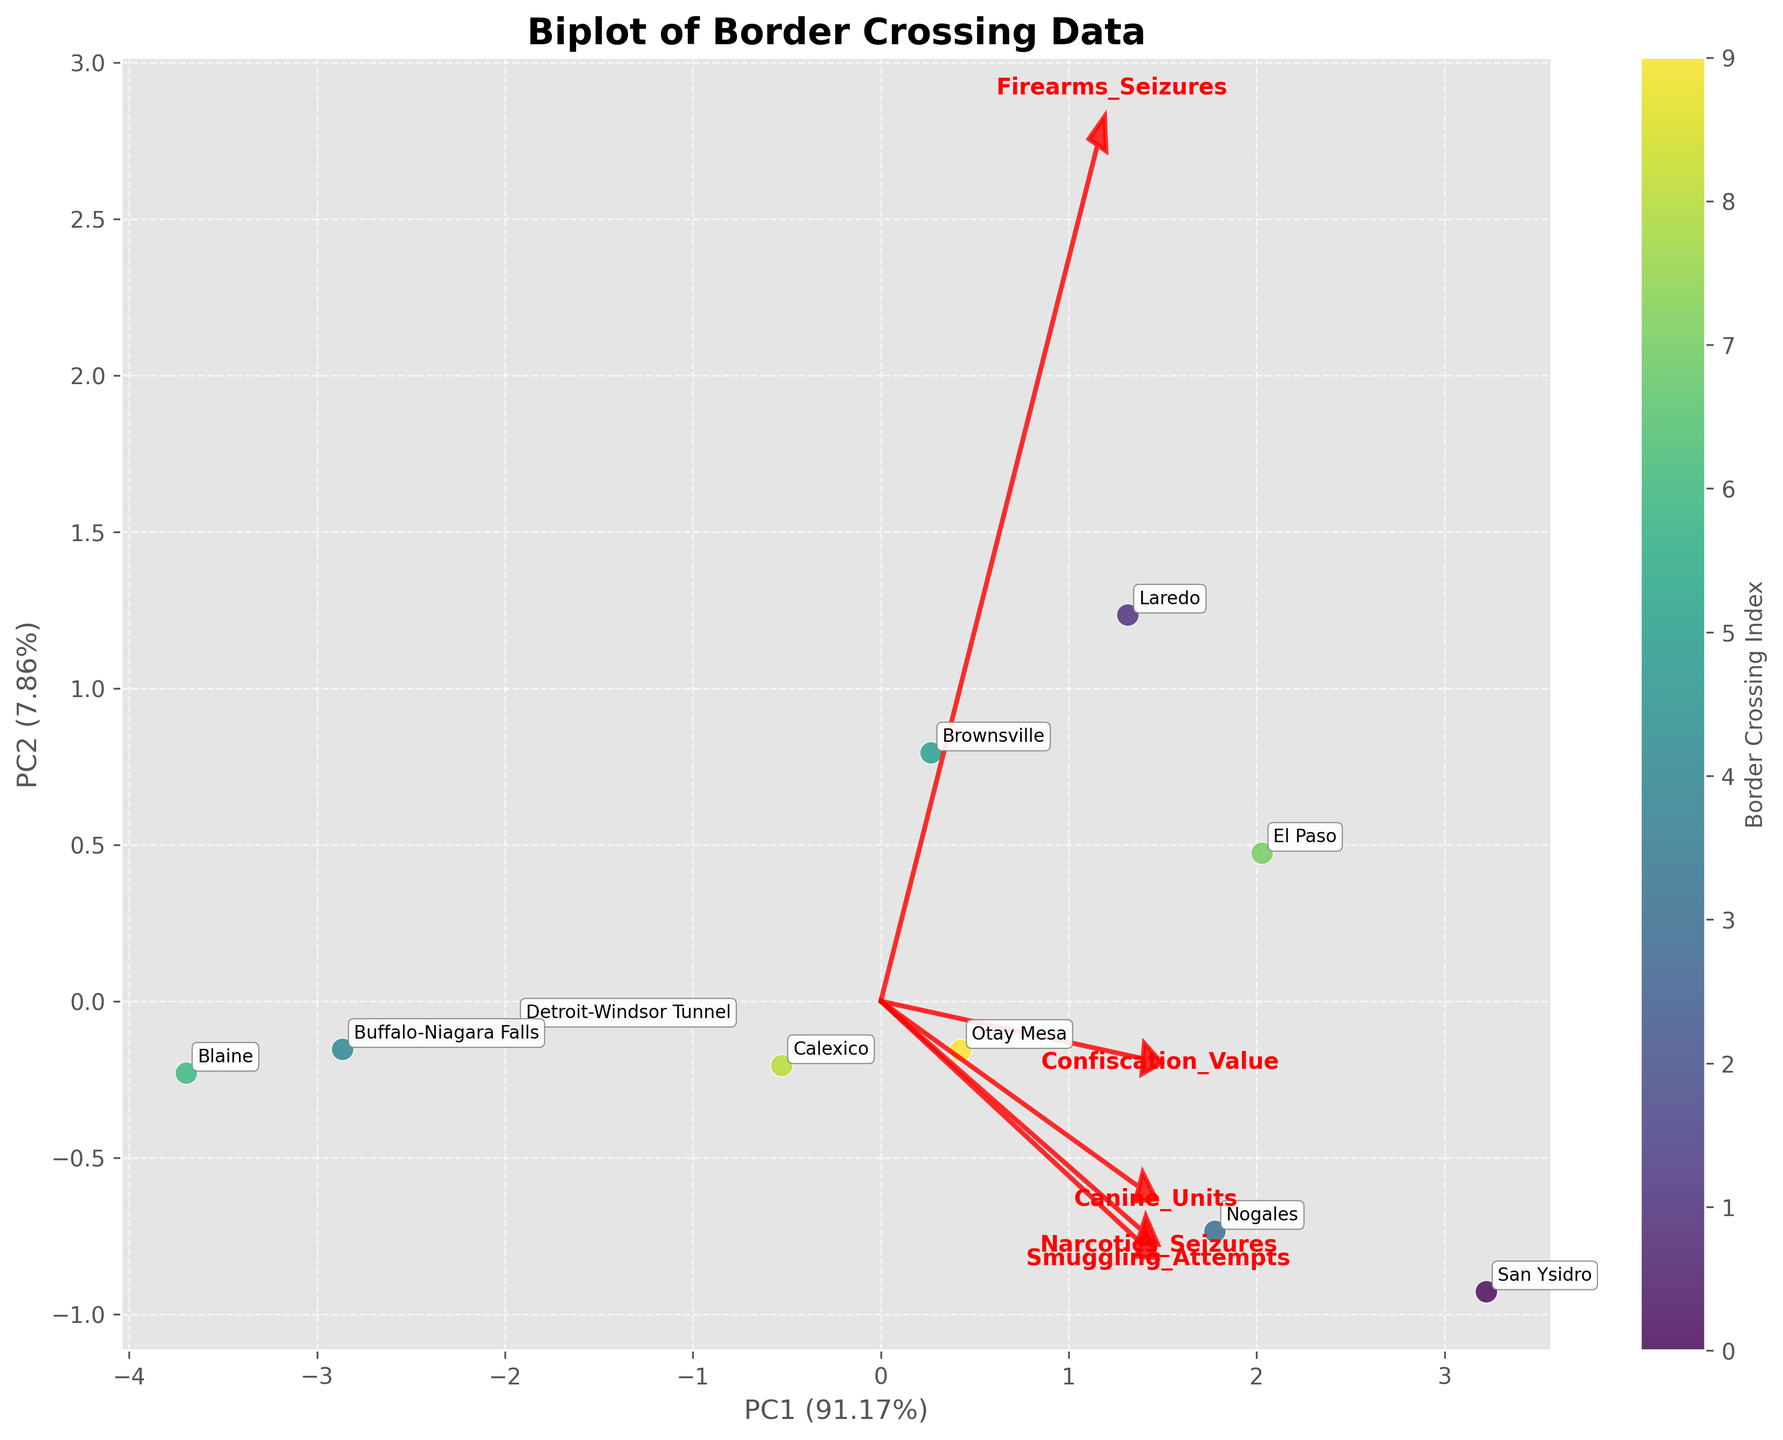How many border crossings are represented in the plot? The plot labels each border crossing on the biplot. Counting the labels gives the total number of border crossings represented in the plot.
Answer: 10 Which border crossing point has the highest number of smuggling attempts? The data labels in the plot show each border crossing point. To determine the one with the highest number of smuggling attempts, look for the label with the highest coordinate along the corresponding feature vector. "San Ysidro" is associated with the highest smuggling attempts.
Answer: San Ysidro What proportion of the variance is explained by PC1? The x-axis title in the biplot includes the proportion of variance explained by PC1.
Answer: (about) 45.2% Which border crossing has the lowest confiscation value? Each border crossing point's label provides visual information. Identify the one with the lowest coordinate along the 'Confiscation Value' vector, which would correspond to "Blaine."
Answer: Blaine How does the number of canine units relate to narcotics seizures in the plot? Examine the direction and length of the 'Canine_Units' and 'Narcotics_Seizures' feature vectors. Longer and similarly oriented vectors suggest a positive relationship.
Answer: Positive relationship Which two features have the strongest correlation according to the biplot? Strong correlation is indicated by vectors that are closely aligned. Here, 'Narcotics_Seizures' and 'Smuggling_Attempts' vectors appear to be the most closely aligned.
Answer: Smuggling_Attempts and Narcotics_Seizures What is the range of values represented by the 'PC2' axis? Look at the PC2 axis on the biplot and note the values ranging from the lowest to the highest points. This is approximately from -2 to 2.
Answer: -2 to 2 Compare the positions of "Laredo" and "San Ysidro" on the plot. Which one has a higher number of smuggling attempts and confiscation value? "San Ysidro" is plotted further along the vectors representing 'Smuggling_Attempts' and 'Confiscation_Value,' indicating higher values in both metrics compared to "Laredo."
Answer: San Ysidro What does the direction of the 'Firearms_Seizures' vector suggest about its correlation with 'Canine_Units'? Since 'Firearms_Seizures' and 'Canine_Units' vectors point in somewhat similar directions, a positive correlation is suggested between these variables.
Answer: Positive correlation 